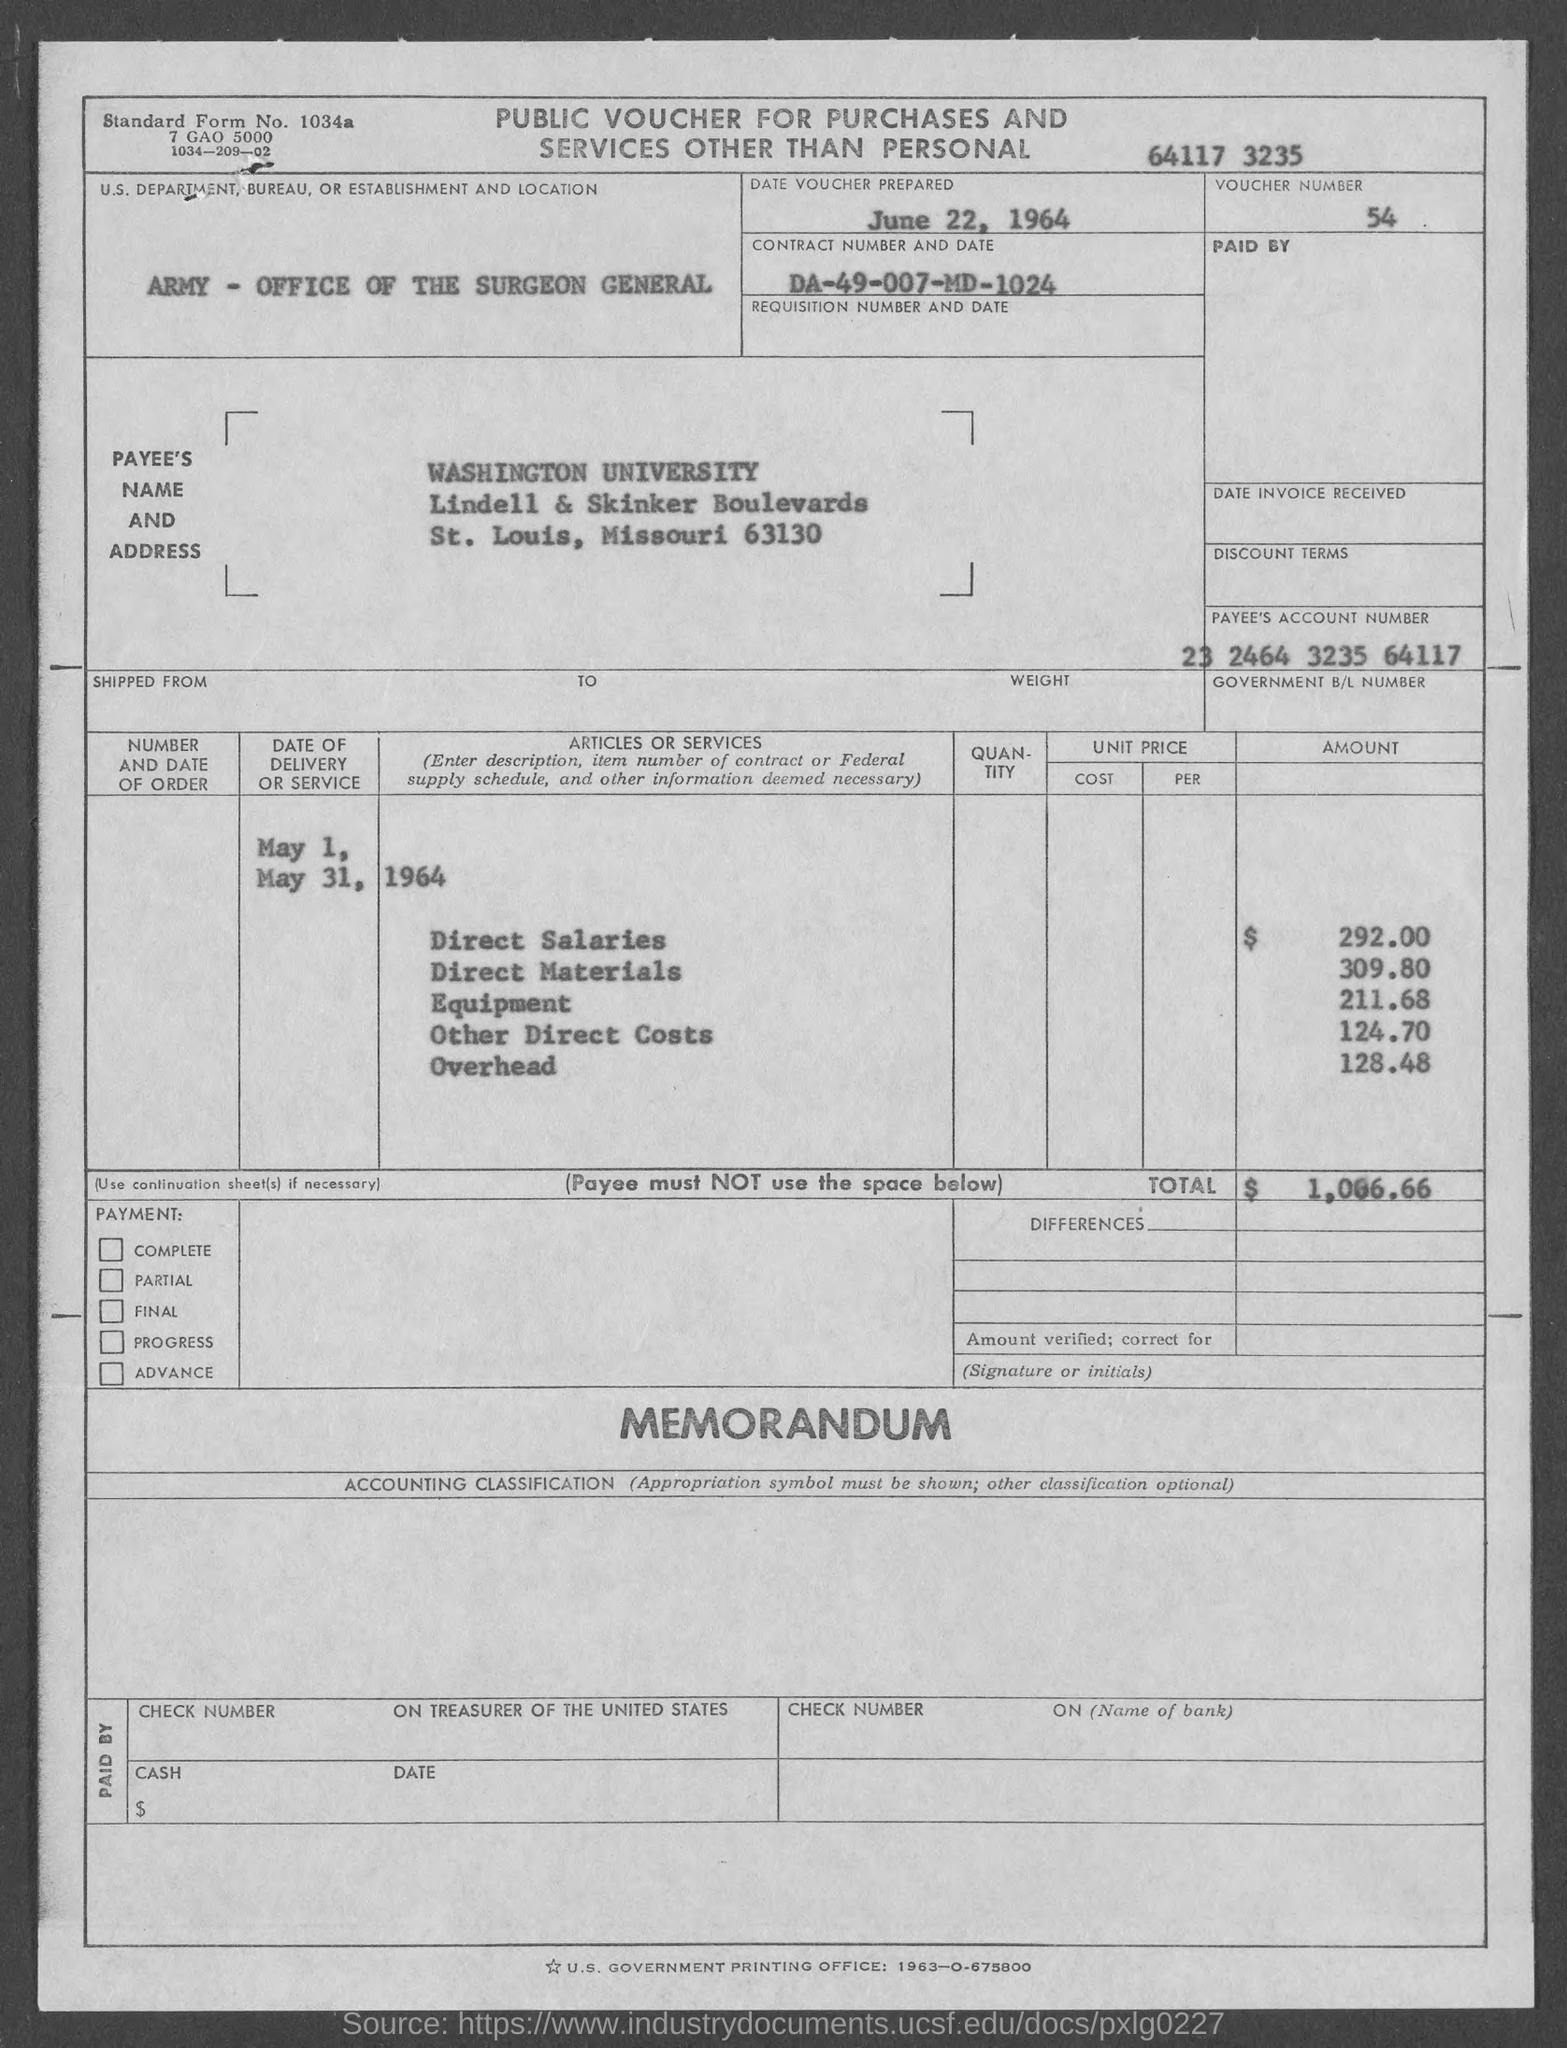Point out several critical features in this image. The total amount is $1,066.66. The voucher number is 54. The contract number is DA-49-007-MD-1024. Washington University is located in the state of Missouri. Please provide the account number of the payee, which is 23 2464 3235 64117. 